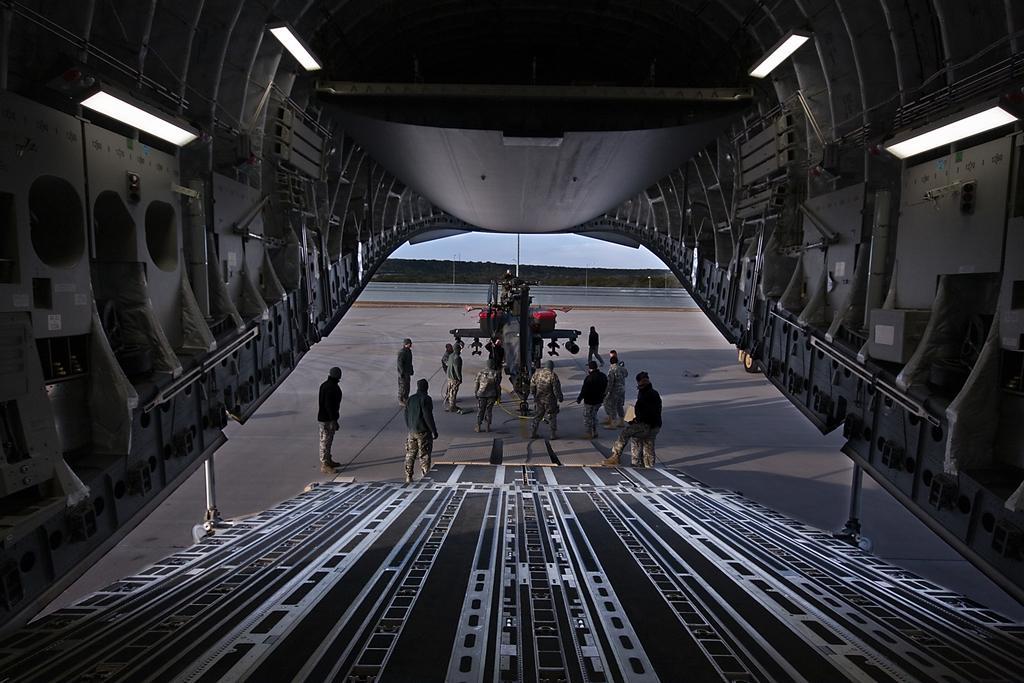Describe this image in one or two sentences. This is an inside picture of an aircraft. We can see the ramp and we can see some people standing. In the center we can see the fighter jet. We can also see a pole and some fence. 